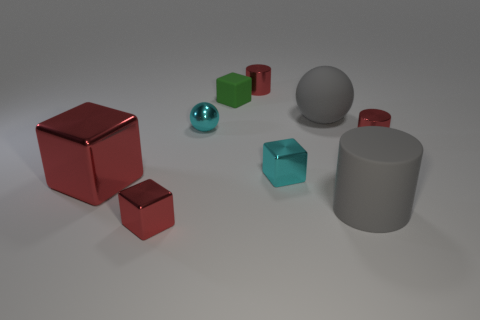The big thing that is the same material as the small sphere is what shape?
Offer a terse response. Cube. Do the red object that is right of the large rubber cylinder and the matte thing in front of the small ball have the same shape?
Your response must be concise. Yes. Is the number of cyan metallic objects behind the green rubber object less than the number of shiny spheres that are behind the tiny red metallic block?
Your answer should be very brief. Yes. There is a thing that is the same color as the big ball; what shape is it?
Give a very brief answer. Cylinder. How many gray rubber balls are the same size as the metallic ball?
Keep it short and to the point. 0. Does the sphere behind the cyan shiny ball have the same material as the small sphere?
Provide a succinct answer. No. Are there any brown shiny cylinders?
Make the answer very short. No. The green block that is made of the same material as the big cylinder is what size?
Your answer should be very brief. Small. Are there any small metallic balls of the same color as the rubber cylinder?
Your response must be concise. No. There is a small cylinder that is in front of the cyan ball; does it have the same color as the big object in front of the big red metallic object?
Your response must be concise. No. 